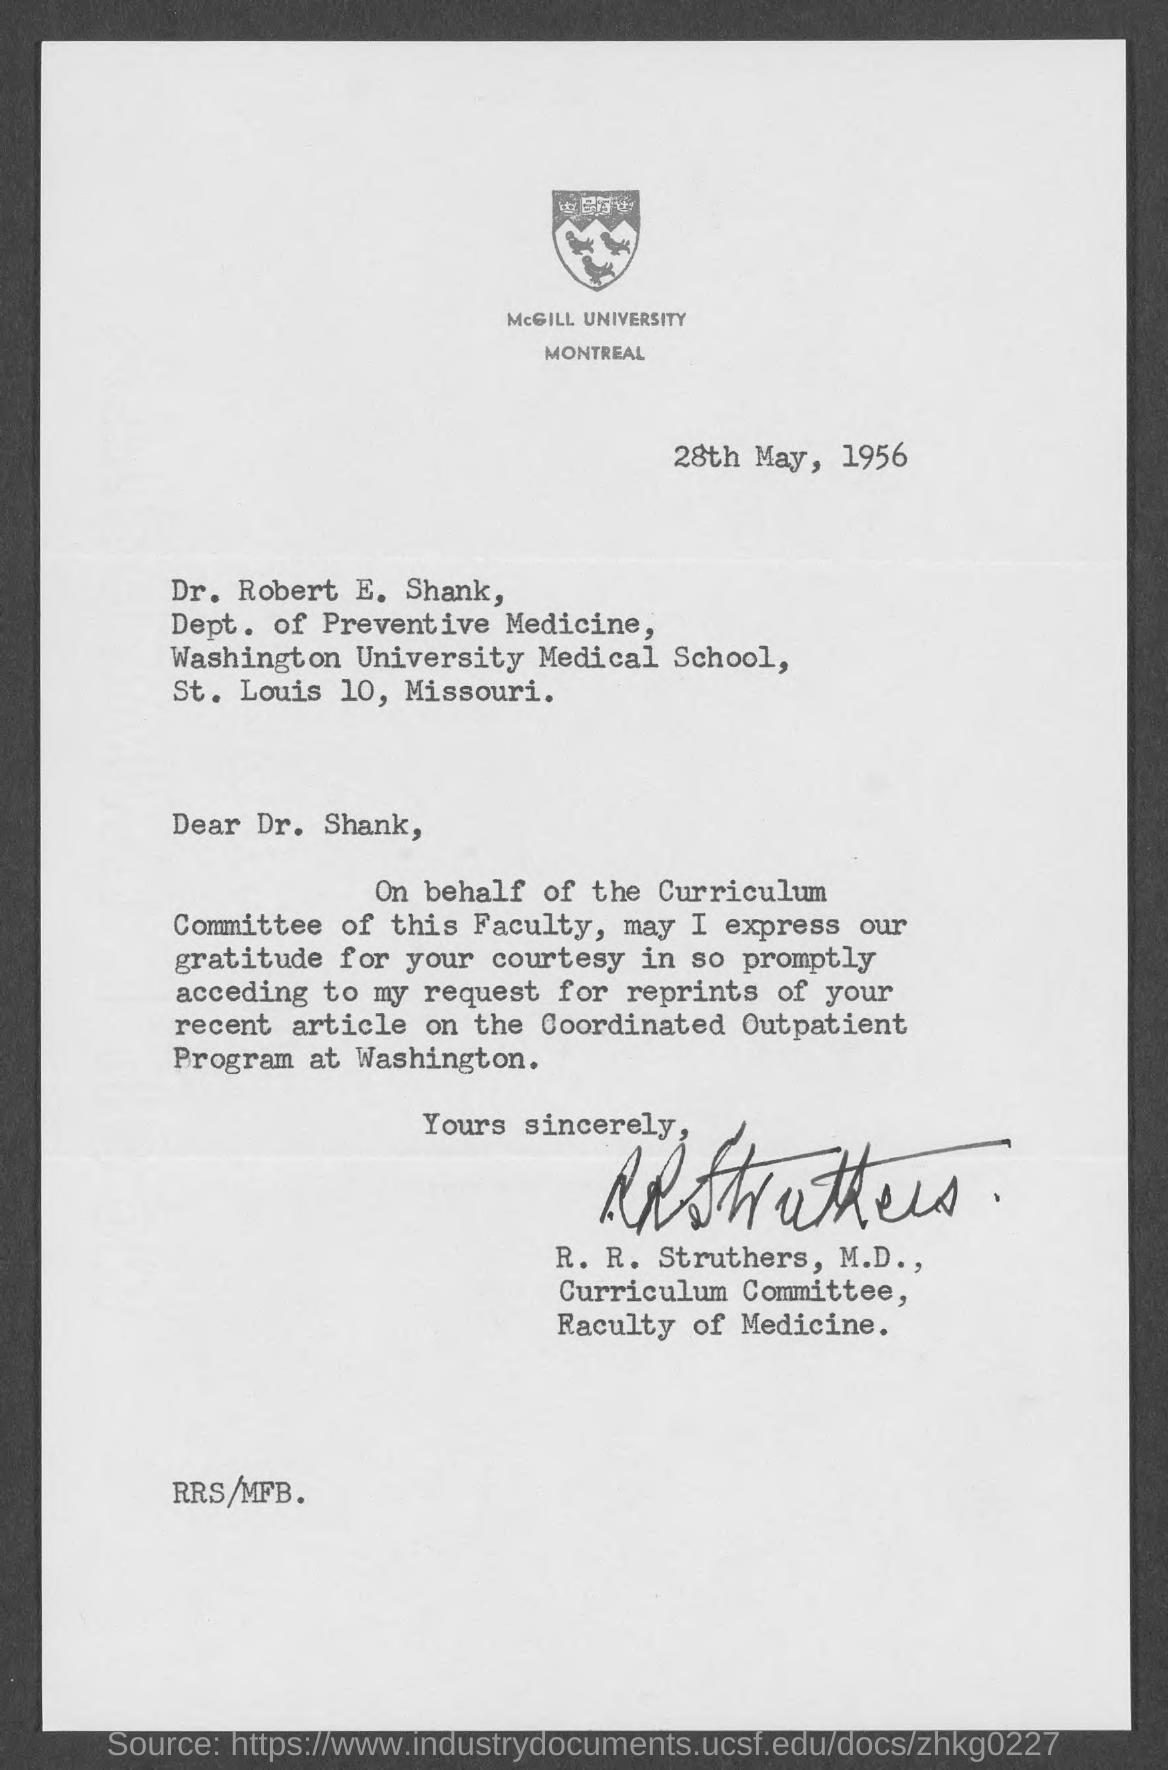Specify some key components in this picture. The date mentioned in the letter is 28th May, 1956. Montreal is the location of McGill University. 